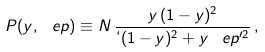Convert formula to latex. <formula><loc_0><loc_0><loc_500><loc_500>P ( y , \ e p ) \equiv N \, \frac { y \, ( 1 - y ) ^ { 2 } } { \lq ( 1 - y ) ^ { 2 } + y \, \ e p \rq ^ { 2 } } \, ,</formula> 